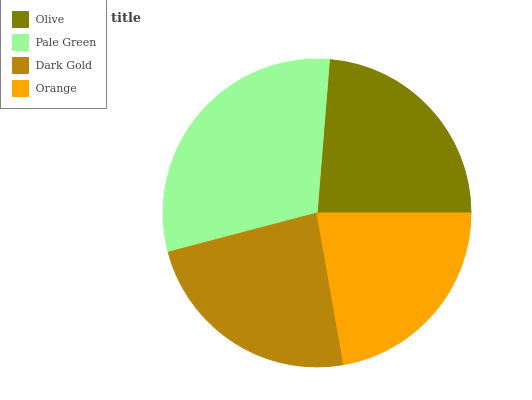Is Orange the minimum?
Answer yes or no. Yes. Is Pale Green the maximum?
Answer yes or no. Yes. Is Dark Gold the minimum?
Answer yes or no. No. Is Dark Gold the maximum?
Answer yes or no. No. Is Pale Green greater than Dark Gold?
Answer yes or no. Yes. Is Dark Gold less than Pale Green?
Answer yes or no. Yes. Is Dark Gold greater than Pale Green?
Answer yes or no. No. Is Pale Green less than Dark Gold?
Answer yes or no. No. Is Olive the high median?
Answer yes or no. Yes. Is Dark Gold the low median?
Answer yes or no. Yes. Is Pale Green the high median?
Answer yes or no. No. Is Olive the low median?
Answer yes or no. No. 